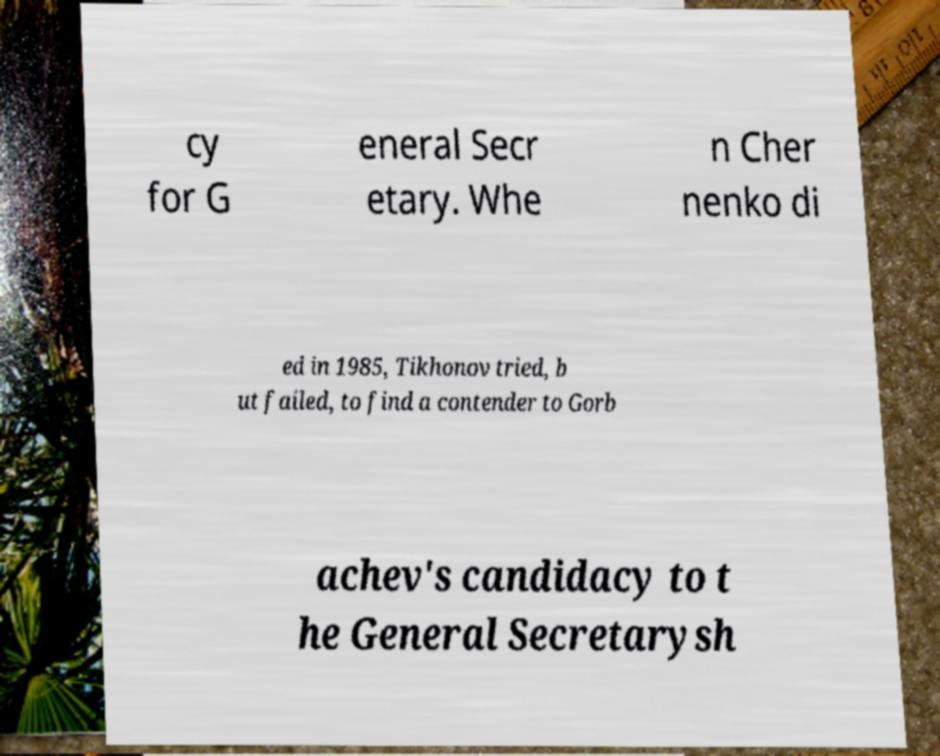For documentation purposes, I need the text within this image transcribed. Could you provide that? cy for G eneral Secr etary. Whe n Cher nenko di ed in 1985, Tikhonov tried, b ut failed, to find a contender to Gorb achev's candidacy to t he General Secretarysh 